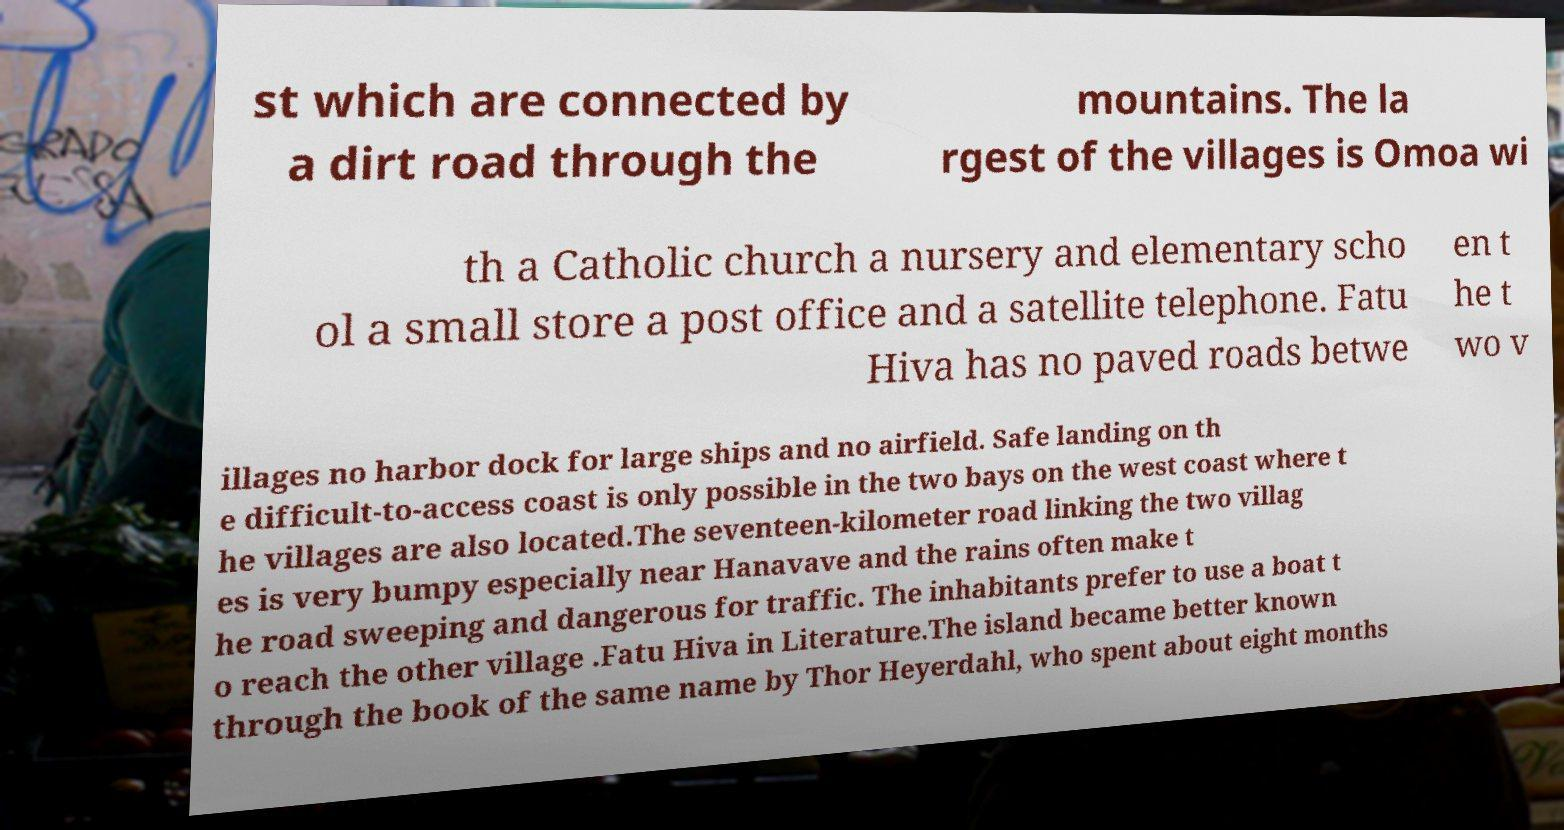Please identify and transcribe the text found in this image. st which are connected by a dirt road through the mountains. The la rgest of the villages is Omoa wi th a Catholic church a nursery and elementary scho ol a small store a post office and a satellite telephone. Fatu Hiva has no paved roads betwe en t he t wo v illages no harbor dock for large ships and no airfield. Safe landing on th e difficult-to-access coast is only possible in the two bays on the west coast where t he villages are also located.The seventeen-kilometer road linking the two villag es is very bumpy especially near Hanavave and the rains often make t he road sweeping and dangerous for traffic. The inhabitants prefer to use a boat t o reach the other village .Fatu Hiva in Literature.The island became better known through the book of the same name by Thor Heyerdahl, who spent about eight months 